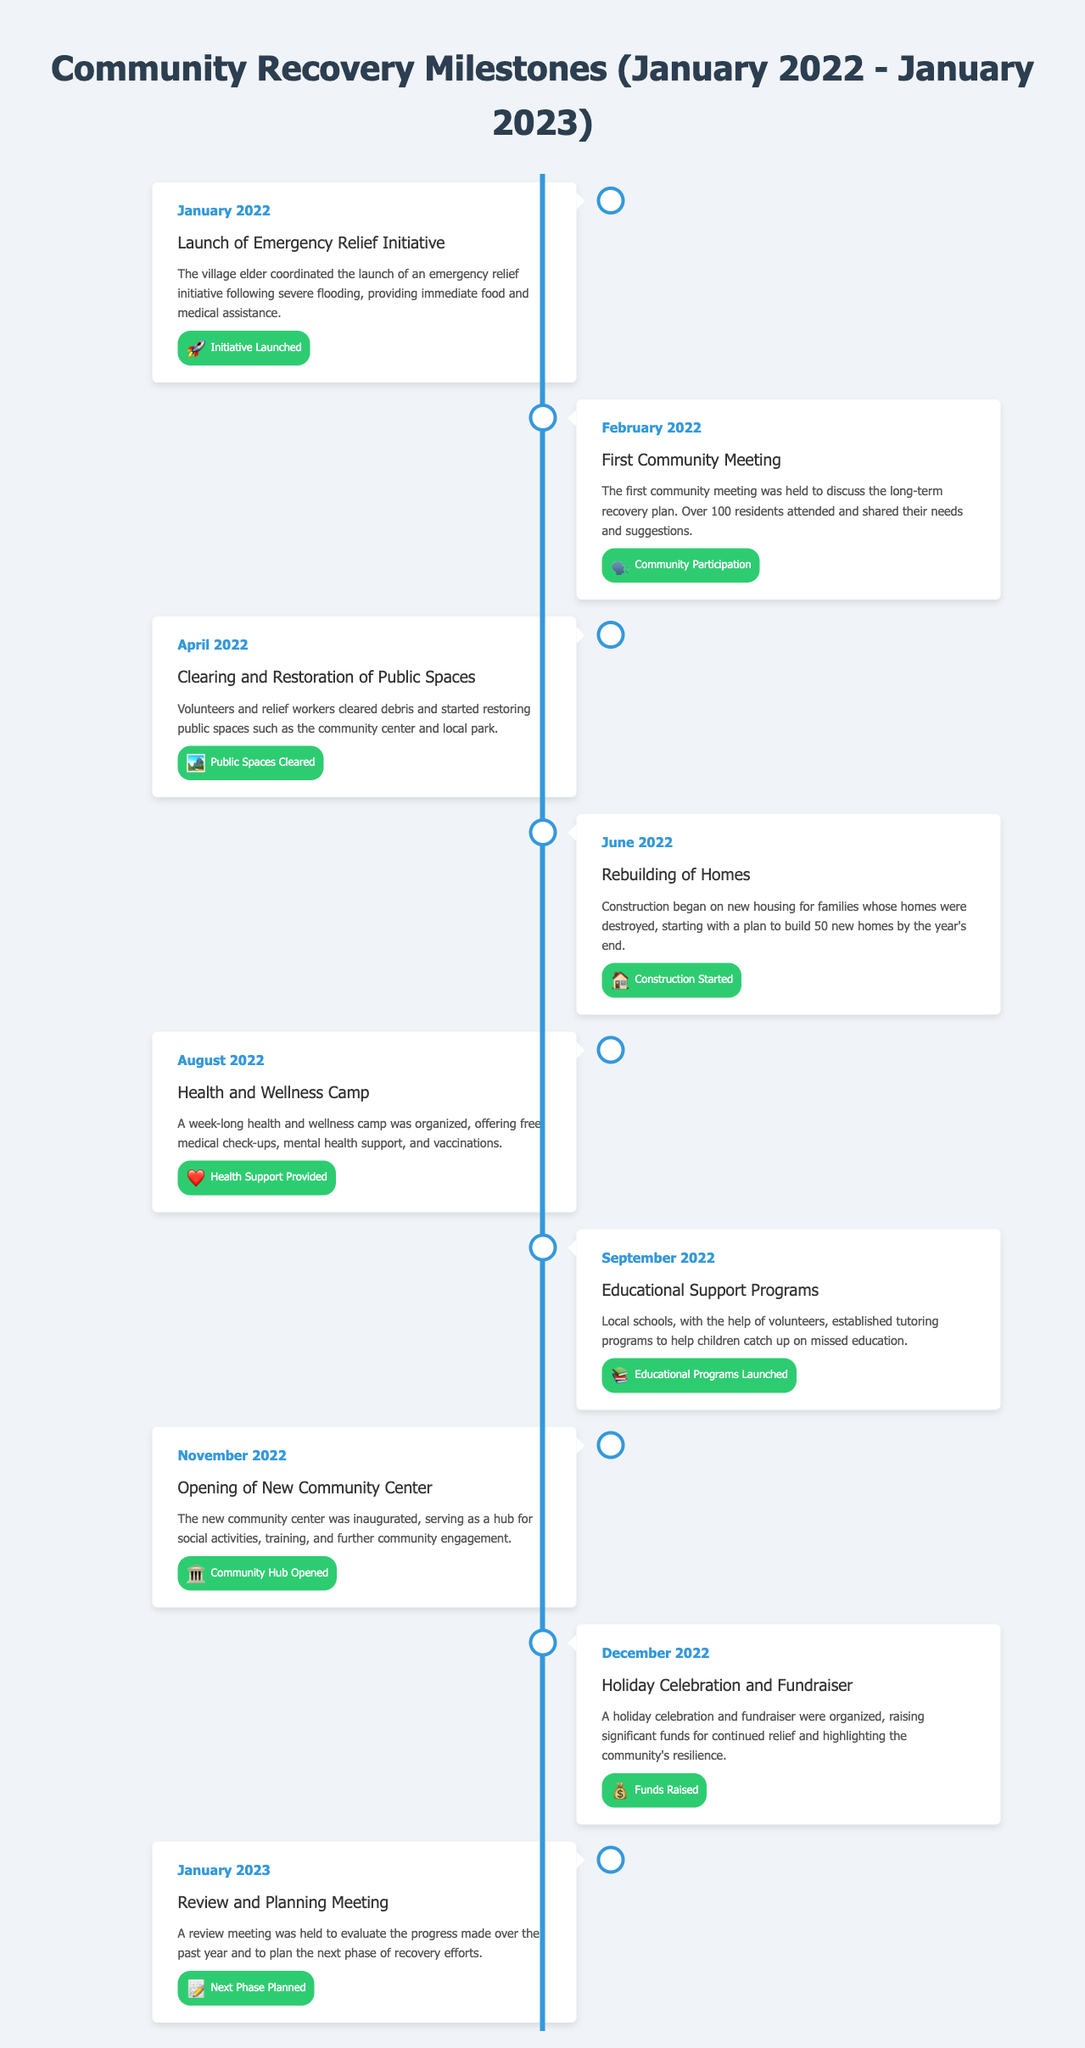What event launched the community recovery efforts? The village elder coordinated the launch of an emergency relief initiative following severe flooding.
Answer: Emergency Relief Initiative When was the first community meeting held? The first community meeting took place in February 2022 to discuss long-term recovery plans.
Answer: February 2022 How many new homes were planned for construction by the end of the year? The document states that the plan was to build 50 new homes by the year's end.
Answer: 50 What was organized in August 2022? The document mentions a week-long health and wellness camp that provided various health services.
Answer: Health and Wellness Camp What was inaugurated in November 2022? The inauguration of a new community center is highlighted as a significant milestone in the timeline.
Answer: New Community Center What kind of programs were established in September 2022? Local schools established tutoring programs to help children catch up on missed education.
Answer: Educational Support Programs What significant event took place in December 2022? The holiday celebration and fundraiser were organized to raise funds for continued relief efforts.
Answer: Holiday Celebration and Fundraiser What was the purpose of the review meeting in January 2023? The meeting was held to evaluate progress and plan the next phase of recovery efforts.
Answer: Evaluate progress and plan next phase 